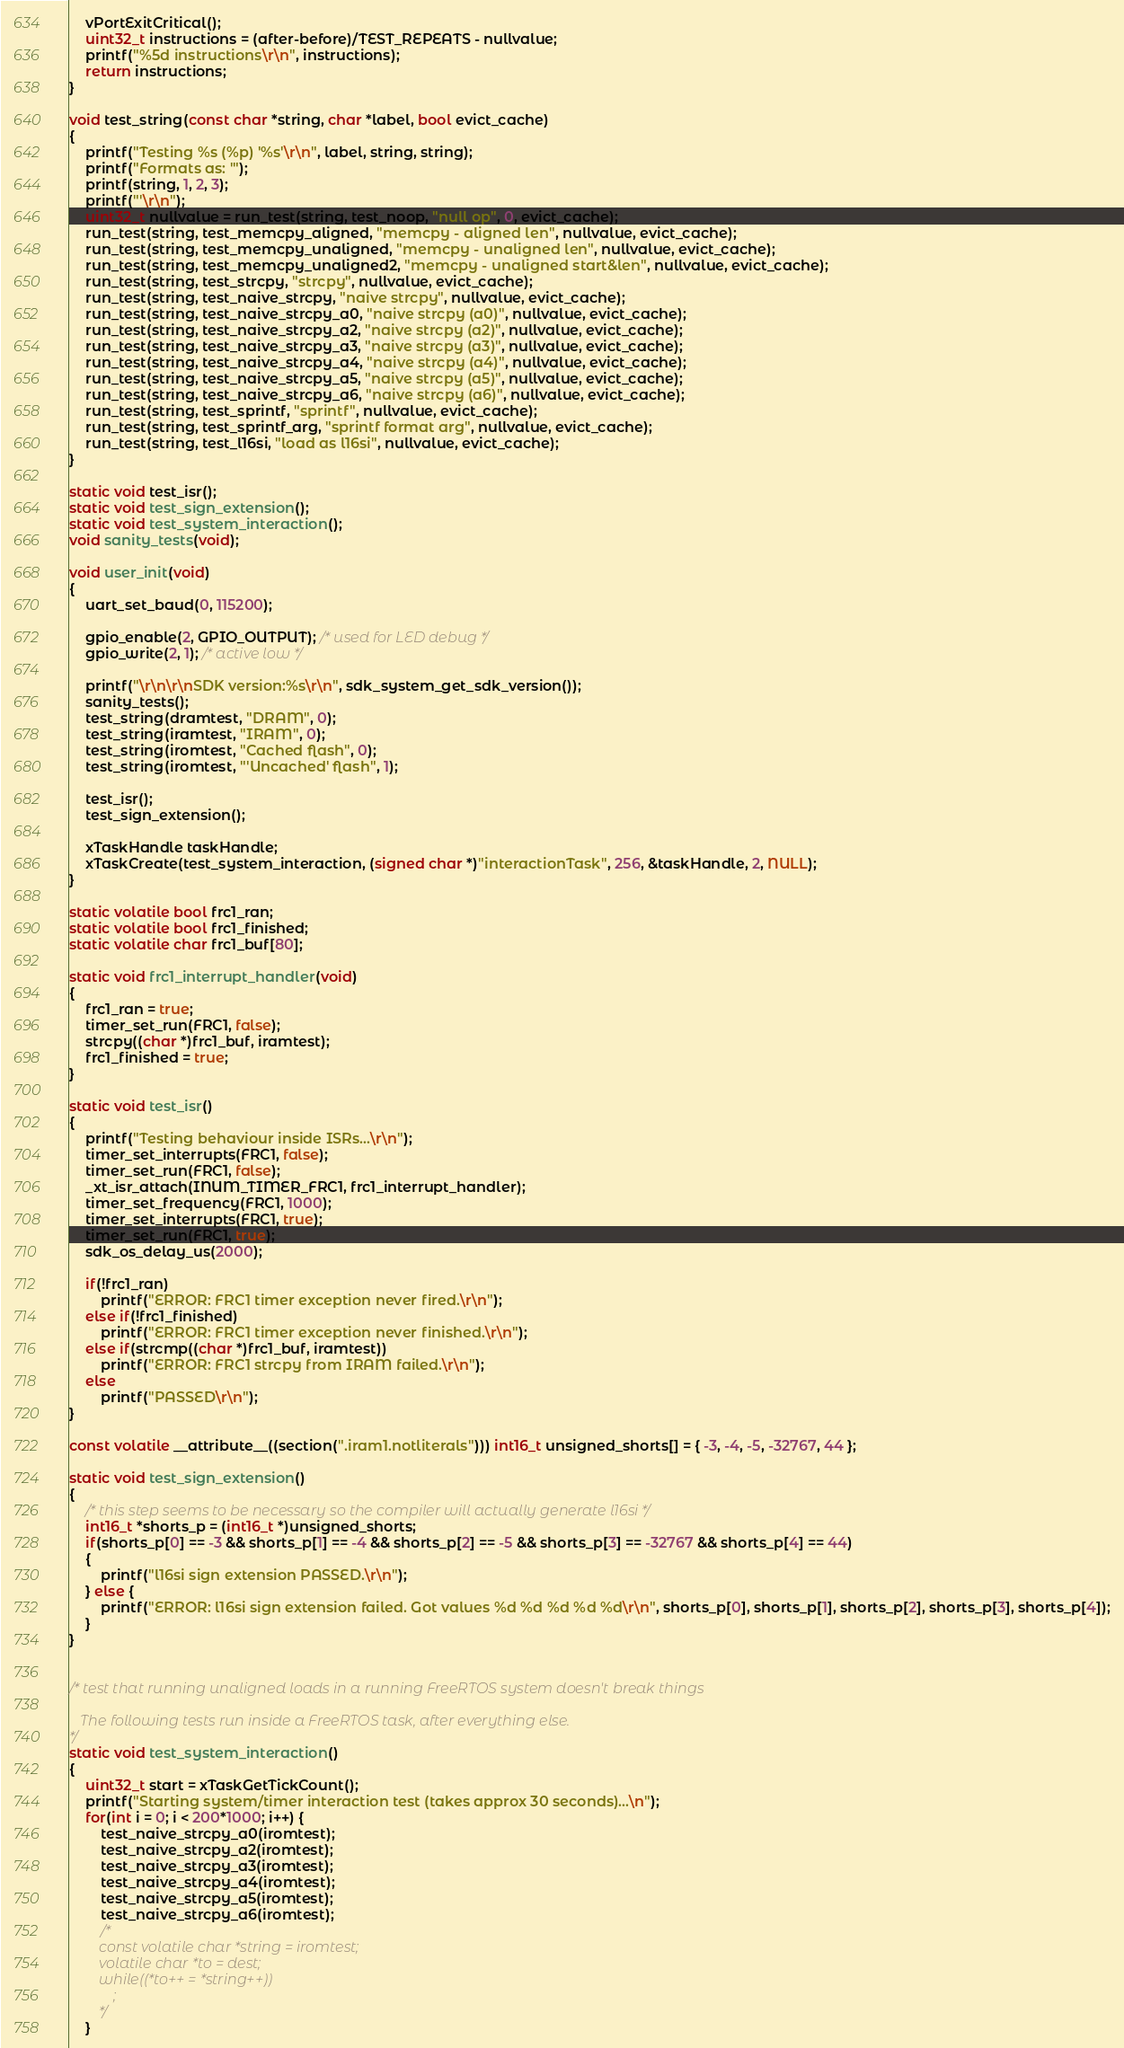<code> <loc_0><loc_0><loc_500><loc_500><_C_>    vPortExitCritical();
    uint32_t instructions = (after-before)/TEST_REPEATS - nullvalue;
    printf("%5d instructions\r\n", instructions);
    return instructions;
}

void test_string(const char *string, char *label, bool evict_cache)
{
    printf("Testing %s (%p) '%s'\r\n", label, string, string);
    printf("Formats as: '");
    printf(string, 1, 2, 3);
    printf("'\r\n");
    uint32_t nullvalue = run_test(string, test_noop, "null op", 0, evict_cache);
    run_test(string, test_memcpy_aligned, "memcpy - aligned len", nullvalue, evict_cache);
    run_test(string, test_memcpy_unaligned, "memcpy - unaligned len", nullvalue, evict_cache);
    run_test(string, test_memcpy_unaligned2, "memcpy - unaligned start&len", nullvalue, evict_cache);
    run_test(string, test_strcpy, "strcpy", nullvalue, evict_cache);
    run_test(string, test_naive_strcpy, "naive strcpy", nullvalue, evict_cache);
    run_test(string, test_naive_strcpy_a0, "naive strcpy (a0)", nullvalue, evict_cache);
    run_test(string, test_naive_strcpy_a2, "naive strcpy (a2)", nullvalue, evict_cache);
    run_test(string, test_naive_strcpy_a3, "naive strcpy (a3)", nullvalue, evict_cache);
    run_test(string, test_naive_strcpy_a4, "naive strcpy (a4)", nullvalue, evict_cache);
    run_test(string, test_naive_strcpy_a5, "naive strcpy (a5)", nullvalue, evict_cache);
    run_test(string, test_naive_strcpy_a6, "naive strcpy (a6)", nullvalue, evict_cache);
    run_test(string, test_sprintf, "sprintf", nullvalue, evict_cache);
    run_test(string, test_sprintf_arg, "sprintf format arg", nullvalue, evict_cache);
    run_test(string, test_l16si, "load as l16si", nullvalue, evict_cache);
}

static void test_isr();
static void test_sign_extension();
static void test_system_interaction();
void sanity_tests(void);

void user_init(void)
{
    uart_set_baud(0, 115200);

    gpio_enable(2, GPIO_OUTPUT); /* used for LED debug */
    gpio_write(2, 1); /* active low */

    printf("\r\n\r\nSDK version:%s\r\n", sdk_system_get_sdk_version());
    sanity_tests();
    test_string(dramtest, "DRAM", 0);
    test_string(iramtest, "IRAM", 0);
    test_string(iromtest, "Cached flash", 0);
    test_string(iromtest, "'Uncached' flash", 1);

    test_isr();
    test_sign_extension();

    xTaskHandle taskHandle;
    xTaskCreate(test_system_interaction, (signed char *)"interactionTask", 256, &taskHandle, 2, NULL);
}

static volatile bool frc1_ran;
static volatile bool frc1_finished;
static volatile char frc1_buf[80];

static void frc1_interrupt_handler(void)
{
    frc1_ran = true;
    timer_set_run(FRC1, false);
    strcpy((char *)frc1_buf, iramtest);
    frc1_finished = true;
}

static void test_isr()
{
    printf("Testing behaviour inside ISRs...\r\n");
    timer_set_interrupts(FRC1, false);
    timer_set_run(FRC1, false);
    _xt_isr_attach(INUM_TIMER_FRC1, frc1_interrupt_handler);
    timer_set_frequency(FRC1, 1000);
    timer_set_interrupts(FRC1, true);
    timer_set_run(FRC1, true);
    sdk_os_delay_us(2000);

    if(!frc1_ran)
        printf("ERROR: FRC1 timer exception never fired.\r\n");
    else if(!frc1_finished)
        printf("ERROR: FRC1 timer exception never finished.\r\n");
    else if(strcmp((char *)frc1_buf, iramtest))
        printf("ERROR: FRC1 strcpy from IRAM failed.\r\n");
    else
        printf("PASSED\r\n");
}

const volatile __attribute__((section(".iram1.notliterals"))) int16_t unsigned_shorts[] = { -3, -4, -5, -32767, 44 };

static void test_sign_extension()
{
    /* this step seems to be necessary so the compiler will actually generate l16si */
    int16_t *shorts_p = (int16_t *)unsigned_shorts;
    if(shorts_p[0] == -3 && shorts_p[1] == -4 && shorts_p[2] == -5 && shorts_p[3] == -32767 && shorts_p[4] == 44)
    {
        printf("l16si sign extension PASSED.\r\n");
    } else {
        printf("ERROR: l16si sign extension failed. Got values %d %d %d %d %d\r\n", shorts_p[0], shorts_p[1], shorts_p[2], shorts_p[3], shorts_p[4]);
    }
}


/* test that running unaligned loads in a running FreeRTOS system doesn't break things

   The following tests run inside a FreeRTOS task, after everything else.
*/
static void test_system_interaction()
{
    uint32_t start = xTaskGetTickCount();
    printf("Starting system/timer interaction test (takes approx 30 seconds)...\n");
    for(int i = 0; i < 200*1000; i++) {
        test_naive_strcpy_a0(iromtest);
        test_naive_strcpy_a2(iromtest);
        test_naive_strcpy_a3(iromtest);
        test_naive_strcpy_a4(iromtest);
        test_naive_strcpy_a5(iromtest);
        test_naive_strcpy_a6(iromtest);
        /*
        const volatile char *string = iromtest;
        volatile char *to = dest;
        while((*to++ = *string++))
            ;
        */
    }</code> 